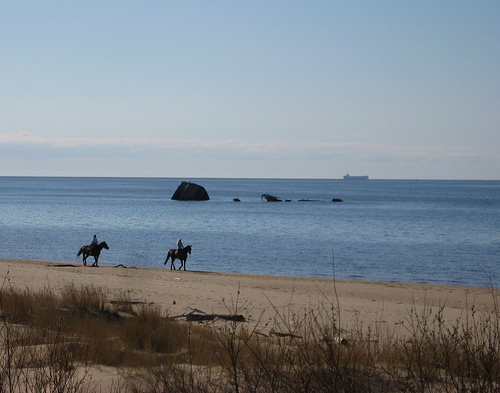What might be some environmental benefits of having natural areas like the one shown in the image? Natural areas such as the one depicted play a crucial role in environmental health. They provide habitats for wildlife, help to maintain biodiversity, act as buffers for coastal erosion, and serve as filters for pollutants running off into bodies of water. Additionally, they offer opportunities for recreation and can have a positive psychological impact on people who visit them, fostering a deeper appreciation for environmental conservation. What activities could people engage in this type of environment? In a coastal setting like this, individuals might enjoy various activities, such as horseback riding, as shown in the image, along with walking, bird watching, or simply relaxing by the water. More adventurous visitors might engage in watersports like kayaking or paddleboarding if conditions permit. It’s also an ideal environment for environmental education and photography due to the diverse wildlife and scenic landscapes. 